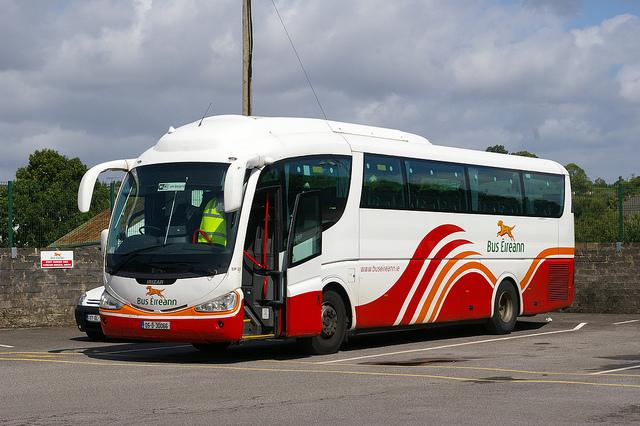Why is the man wearing a yellow vest? Please explain your reasoning. visibility. To be easily be seen in the area as it make him different. 